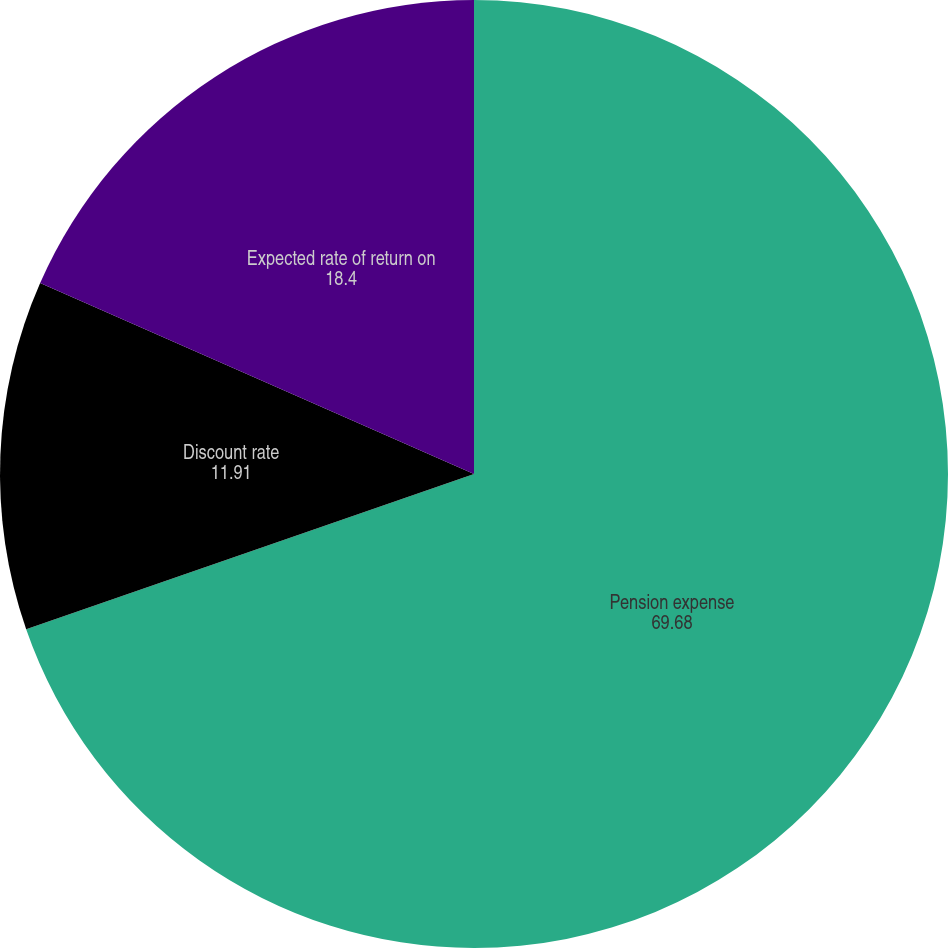<chart> <loc_0><loc_0><loc_500><loc_500><pie_chart><fcel>Pension expense<fcel>Discount rate<fcel>Expected rate of return on<nl><fcel>69.68%<fcel>11.91%<fcel>18.4%<nl></chart> 